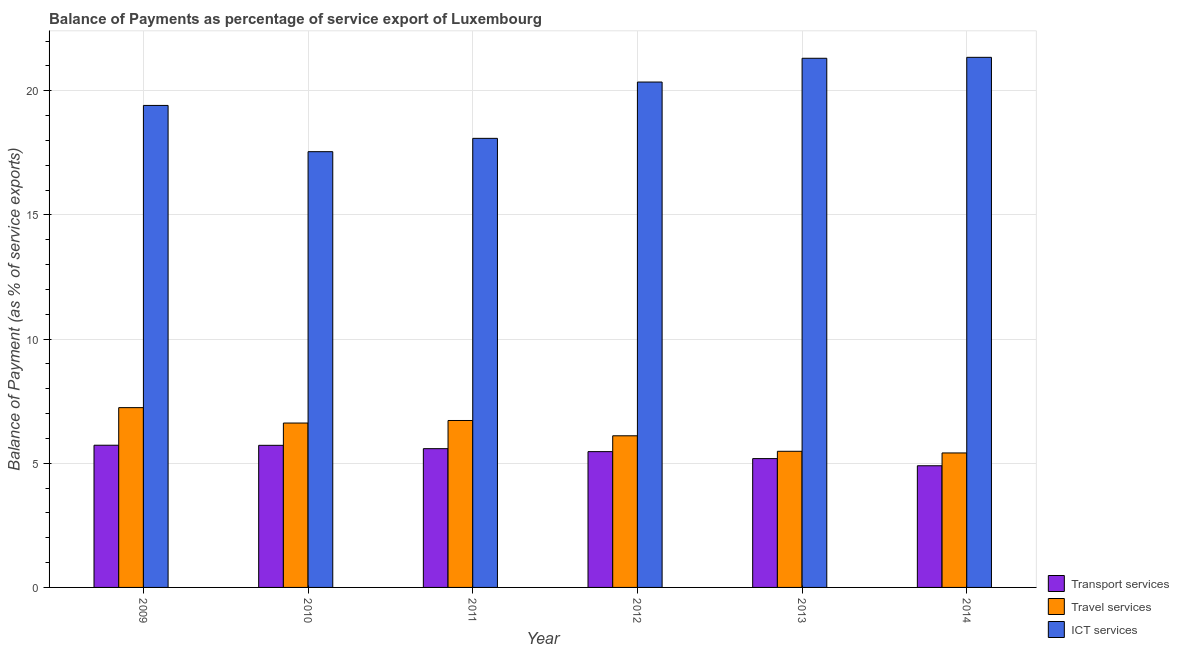How many groups of bars are there?
Provide a succinct answer. 6. Are the number of bars on each tick of the X-axis equal?
Provide a short and direct response. Yes. How many bars are there on the 3rd tick from the right?
Keep it short and to the point. 3. What is the balance of payment of ict services in 2011?
Give a very brief answer. 18.08. Across all years, what is the maximum balance of payment of travel services?
Offer a very short reply. 7.24. Across all years, what is the minimum balance of payment of ict services?
Offer a terse response. 17.55. In which year was the balance of payment of travel services maximum?
Provide a short and direct response. 2009. In which year was the balance of payment of travel services minimum?
Make the answer very short. 2014. What is the total balance of payment of transport services in the graph?
Provide a succinct answer. 32.59. What is the difference between the balance of payment of transport services in 2009 and that in 2012?
Provide a short and direct response. 0.26. What is the difference between the balance of payment of ict services in 2014 and the balance of payment of travel services in 2013?
Your answer should be very brief. 0.04. What is the average balance of payment of travel services per year?
Provide a short and direct response. 6.26. In the year 2013, what is the difference between the balance of payment of ict services and balance of payment of travel services?
Give a very brief answer. 0. In how many years, is the balance of payment of travel services greater than 1 %?
Your answer should be compact. 6. What is the ratio of the balance of payment of ict services in 2009 to that in 2010?
Ensure brevity in your answer.  1.11. Is the balance of payment of travel services in 2010 less than that in 2011?
Ensure brevity in your answer.  Yes. What is the difference between the highest and the second highest balance of payment of ict services?
Provide a succinct answer. 0.04. What is the difference between the highest and the lowest balance of payment of travel services?
Your answer should be very brief. 1.82. Is the sum of the balance of payment of travel services in 2009 and 2011 greater than the maximum balance of payment of ict services across all years?
Provide a short and direct response. Yes. What does the 3rd bar from the left in 2013 represents?
Your response must be concise. ICT services. What does the 2nd bar from the right in 2011 represents?
Your answer should be compact. Travel services. Is it the case that in every year, the sum of the balance of payment of transport services and balance of payment of travel services is greater than the balance of payment of ict services?
Offer a terse response. No. Are all the bars in the graph horizontal?
Offer a very short reply. No. How many years are there in the graph?
Offer a very short reply. 6. How many legend labels are there?
Your answer should be compact. 3. What is the title of the graph?
Provide a succinct answer. Balance of Payments as percentage of service export of Luxembourg. What is the label or title of the Y-axis?
Keep it short and to the point. Balance of Payment (as % of service exports). What is the Balance of Payment (as % of service exports) in Transport services in 2009?
Offer a very short reply. 5.73. What is the Balance of Payment (as % of service exports) of Travel services in 2009?
Ensure brevity in your answer.  7.24. What is the Balance of Payment (as % of service exports) in ICT services in 2009?
Give a very brief answer. 19.41. What is the Balance of Payment (as % of service exports) in Transport services in 2010?
Ensure brevity in your answer.  5.72. What is the Balance of Payment (as % of service exports) of Travel services in 2010?
Offer a very short reply. 6.62. What is the Balance of Payment (as % of service exports) of ICT services in 2010?
Provide a short and direct response. 17.55. What is the Balance of Payment (as % of service exports) in Transport services in 2011?
Your answer should be compact. 5.59. What is the Balance of Payment (as % of service exports) of Travel services in 2011?
Keep it short and to the point. 6.72. What is the Balance of Payment (as % of service exports) in ICT services in 2011?
Provide a short and direct response. 18.08. What is the Balance of Payment (as % of service exports) of Transport services in 2012?
Provide a short and direct response. 5.47. What is the Balance of Payment (as % of service exports) in Travel services in 2012?
Give a very brief answer. 6.11. What is the Balance of Payment (as % of service exports) in ICT services in 2012?
Your response must be concise. 20.35. What is the Balance of Payment (as % of service exports) in Transport services in 2013?
Make the answer very short. 5.19. What is the Balance of Payment (as % of service exports) of Travel services in 2013?
Offer a terse response. 5.48. What is the Balance of Payment (as % of service exports) in ICT services in 2013?
Offer a very short reply. 21.31. What is the Balance of Payment (as % of service exports) in Transport services in 2014?
Give a very brief answer. 4.9. What is the Balance of Payment (as % of service exports) in Travel services in 2014?
Make the answer very short. 5.41. What is the Balance of Payment (as % of service exports) of ICT services in 2014?
Ensure brevity in your answer.  21.34. Across all years, what is the maximum Balance of Payment (as % of service exports) of Transport services?
Keep it short and to the point. 5.73. Across all years, what is the maximum Balance of Payment (as % of service exports) in Travel services?
Your answer should be very brief. 7.24. Across all years, what is the maximum Balance of Payment (as % of service exports) of ICT services?
Provide a short and direct response. 21.34. Across all years, what is the minimum Balance of Payment (as % of service exports) of Transport services?
Make the answer very short. 4.9. Across all years, what is the minimum Balance of Payment (as % of service exports) in Travel services?
Provide a succinct answer. 5.41. Across all years, what is the minimum Balance of Payment (as % of service exports) in ICT services?
Offer a very short reply. 17.55. What is the total Balance of Payment (as % of service exports) of Transport services in the graph?
Ensure brevity in your answer.  32.59. What is the total Balance of Payment (as % of service exports) in Travel services in the graph?
Offer a terse response. 37.58. What is the total Balance of Payment (as % of service exports) of ICT services in the graph?
Keep it short and to the point. 118.04. What is the difference between the Balance of Payment (as % of service exports) in Transport services in 2009 and that in 2010?
Ensure brevity in your answer.  0. What is the difference between the Balance of Payment (as % of service exports) of Travel services in 2009 and that in 2010?
Keep it short and to the point. 0.62. What is the difference between the Balance of Payment (as % of service exports) of ICT services in 2009 and that in 2010?
Your answer should be very brief. 1.86. What is the difference between the Balance of Payment (as % of service exports) of Transport services in 2009 and that in 2011?
Your response must be concise. 0.14. What is the difference between the Balance of Payment (as % of service exports) of Travel services in 2009 and that in 2011?
Provide a short and direct response. 0.52. What is the difference between the Balance of Payment (as % of service exports) in ICT services in 2009 and that in 2011?
Provide a short and direct response. 1.33. What is the difference between the Balance of Payment (as % of service exports) of Transport services in 2009 and that in 2012?
Ensure brevity in your answer.  0.26. What is the difference between the Balance of Payment (as % of service exports) in Travel services in 2009 and that in 2012?
Ensure brevity in your answer.  1.13. What is the difference between the Balance of Payment (as % of service exports) in ICT services in 2009 and that in 2012?
Offer a terse response. -0.94. What is the difference between the Balance of Payment (as % of service exports) in Transport services in 2009 and that in 2013?
Your answer should be compact. 0.54. What is the difference between the Balance of Payment (as % of service exports) of Travel services in 2009 and that in 2013?
Your answer should be very brief. 1.76. What is the difference between the Balance of Payment (as % of service exports) in ICT services in 2009 and that in 2013?
Make the answer very short. -1.9. What is the difference between the Balance of Payment (as % of service exports) in Transport services in 2009 and that in 2014?
Ensure brevity in your answer.  0.83. What is the difference between the Balance of Payment (as % of service exports) of Travel services in 2009 and that in 2014?
Make the answer very short. 1.82. What is the difference between the Balance of Payment (as % of service exports) of ICT services in 2009 and that in 2014?
Provide a succinct answer. -1.94. What is the difference between the Balance of Payment (as % of service exports) of Transport services in 2010 and that in 2011?
Your answer should be compact. 0.13. What is the difference between the Balance of Payment (as % of service exports) in Travel services in 2010 and that in 2011?
Give a very brief answer. -0.1. What is the difference between the Balance of Payment (as % of service exports) of ICT services in 2010 and that in 2011?
Your answer should be very brief. -0.54. What is the difference between the Balance of Payment (as % of service exports) in Transport services in 2010 and that in 2012?
Offer a very short reply. 0.25. What is the difference between the Balance of Payment (as % of service exports) of Travel services in 2010 and that in 2012?
Ensure brevity in your answer.  0.51. What is the difference between the Balance of Payment (as % of service exports) in ICT services in 2010 and that in 2012?
Keep it short and to the point. -2.8. What is the difference between the Balance of Payment (as % of service exports) of Transport services in 2010 and that in 2013?
Your response must be concise. 0.54. What is the difference between the Balance of Payment (as % of service exports) in Travel services in 2010 and that in 2013?
Provide a succinct answer. 1.14. What is the difference between the Balance of Payment (as % of service exports) in ICT services in 2010 and that in 2013?
Provide a succinct answer. -3.76. What is the difference between the Balance of Payment (as % of service exports) of Transport services in 2010 and that in 2014?
Give a very brief answer. 0.82. What is the difference between the Balance of Payment (as % of service exports) of Travel services in 2010 and that in 2014?
Offer a very short reply. 1.2. What is the difference between the Balance of Payment (as % of service exports) of ICT services in 2010 and that in 2014?
Keep it short and to the point. -3.8. What is the difference between the Balance of Payment (as % of service exports) in Transport services in 2011 and that in 2012?
Offer a very short reply. 0.12. What is the difference between the Balance of Payment (as % of service exports) of Travel services in 2011 and that in 2012?
Ensure brevity in your answer.  0.62. What is the difference between the Balance of Payment (as % of service exports) of ICT services in 2011 and that in 2012?
Offer a very short reply. -2.27. What is the difference between the Balance of Payment (as % of service exports) in Transport services in 2011 and that in 2013?
Provide a succinct answer. 0.4. What is the difference between the Balance of Payment (as % of service exports) of Travel services in 2011 and that in 2013?
Your response must be concise. 1.24. What is the difference between the Balance of Payment (as % of service exports) in ICT services in 2011 and that in 2013?
Your answer should be compact. -3.22. What is the difference between the Balance of Payment (as % of service exports) of Transport services in 2011 and that in 2014?
Provide a succinct answer. 0.69. What is the difference between the Balance of Payment (as % of service exports) in Travel services in 2011 and that in 2014?
Provide a short and direct response. 1.31. What is the difference between the Balance of Payment (as % of service exports) in ICT services in 2011 and that in 2014?
Your answer should be compact. -3.26. What is the difference between the Balance of Payment (as % of service exports) of Transport services in 2012 and that in 2013?
Provide a short and direct response. 0.28. What is the difference between the Balance of Payment (as % of service exports) in Travel services in 2012 and that in 2013?
Your response must be concise. 0.62. What is the difference between the Balance of Payment (as % of service exports) in ICT services in 2012 and that in 2013?
Your answer should be very brief. -0.96. What is the difference between the Balance of Payment (as % of service exports) of Transport services in 2012 and that in 2014?
Offer a terse response. 0.57. What is the difference between the Balance of Payment (as % of service exports) of Travel services in 2012 and that in 2014?
Give a very brief answer. 0.69. What is the difference between the Balance of Payment (as % of service exports) in ICT services in 2012 and that in 2014?
Keep it short and to the point. -0.99. What is the difference between the Balance of Payment (as % of service exports) in Transport services in 2013 and that in 2014?
Your answer should be compact. 0.29. What is the difference between the Balance of Payment (as % of service exports) of Travel services in 2013 and that in 2014?
Make the answer very short. 0.07. What is the difference between the Balance of Payment (as % of service exports) of ICT services in 2013 and that in 2014?
Ensure brevity in your answer.  -0.04. What is the difference between the Balance of Payment (as % of service exports) in Transport services in 2009 and the Balance of Payment (as % of service exports) in Travel services in 2010?
Your answer should be compact. -0.89. What is the difference between the Balance of Payment (as % of service exports) of Transport services in 2009 and the Balance of Payment (as % of service exports) of ICT services in 2010?
Your answer should be compact. -11.82. What is the difference between the Balance of Payment (as % of service exports) of Travel services in 2009 and the Balance of Payment (as % of service exports) of ICT services in 2010?
Make the answer very short. -10.31. What is the difference between the Balance of Payment (as % of service exports) in Transport services in 2009 and the Balance of Payment (as % of service exports) in Travel services in 2011?
Give a very brief answer. -1. What is the difference between the Balance of Payment (as % of service exports) of Transport services in 2009 and the Balance of Payment (as % of service exports) of ICT services in 2011?
Your response must be concise. -12.36. What is the difference between the Balance of Payment (as % of service exports) of Travel services in 2009 and the Balance of Payment (as % of service exports) of ICT services in 2011?
Provide a succinct answer. -10.84. What is the difference between the Balance of Payment (as % of service exports) of Transport services in 2009 and the Balance of Payment (as % of service exports) of Travel services in 2012?
Provide a short and direct response. -0.38. What is the difference between the Balance of Payment (as % of service exports) in Transport services in 2009 and the Balance of Payment (as % of service exports) in ICT services in 2012?
Give a very brief answer. -14.62. What is the difference between the Balance of Payment (as % of service exports) of Travel services in 2009 and the Balance of Payment (as % of service exports) of ICT services in 2012?
Make the answer very short. -13.11. What is the difference between the Balance of Payment (as % of service exports) in Transport services in 2009 and the Balance of Payment (as % of service exports) in Travel services in 2013?
Provide a short and direct response. 0.24. What is the difference between the Balance of Payment (as % of service exports) of Transport services in 2009 and the Balance of Payment (as % of service exports) of ICT services in 2013?
Your answer should be very brief. -15.58. What is the difference between the Balance of Payment (as % of service exports) in Travel services in 2009 and the Balance of Payment (as % of service exports) in ICT services in 2013?
Your answer should be very brief. -14.07. What is the difference between the Balance of Payment (as % of service exports) of Transport services in 2009 and the Balance of Payment (as % of service exports) of Travel services in 2014?
Ensure brevity in your answer.  0.31. What is the difference between the Balance of Payment (as % of service exports) in Transport services in 2009 and the Balance of Payment (as % of service exports) in ICT services in 2014?
Your response must be concise. -15.62. What is the difference between the Balance of Payment (as % of service exports) of Travel services in 2009 and the Balance of Payment (as % of service exports) of ICT services in 2014?
Offer a terse response. -14.11. What is the difference between the Balance of Payment (as % of service exports) of Transport services in 2010 and the Balance of Payment (as % of service exports) of Travel services in 2011?
Offer a very short reply. -1. What is the difference between the Balance of Payment (as % of service exports) of Transport services in 2010 and the Balance of Payment (as % of service exports) of ICT services in 2011?
Ensure brevity in your answer.  -12.36. What is the difference between the Balance of Payment (as % of service exports) in Travel services in 2010 and the Balance of Payment (as % of service exports) in ICT services in 2011?
Keep it short and to the point. -11.46. What is the difference between the Balance of Payment (as % of service exports) in Transport services in 2010 and the Balance of Payment (as % of service exports) in Travel services in 2012?
Your answer should be very brief. -0.38. What is the difference between the Balance of Payment (as % of service exports) in Transport services in 2010 and the Balance of Payment (as % of service exports) in ICT services in 2012?
Your answer should be compact. -14.63. What is the difference between the Balance of Payment (as % of service exports) in Travel services in 2010 and the Balance of Payment (as % of service exports) in ICT services in 2012?
Offer a terse response. -13.73. What is the difference between the Balance of Payment (as % of service exports) in Transport services in 2010 and the Balance of Payment (as % of service exports) in Travel services in 2013?
Offer a terse response. 0.24. What is the difference between the Balance of Payment (as % of service exports) of Transport services in 2010 and the Balance of Payment (as % of service exports) of ICT services in 2013?
Your response must be concise. -15.58. What is the difference between the Balance of Payment (as % of service exports) in Travel services in 2010 and the Balance of Payment (as % of service exports) in ICT services in 2013?
Your answer should be compact. -14.69. What is the difference between the Balance of Payment (as % of service exports) of Transport services in 2010 and the Balance of Payment (as % of service exports) of Travel services in 2014?
Your response must be concise. 0.31. What is the difference between the Balance of Payment (as % of service exports) in Transport services in 2010 and the Balance of Payment (as % of service exports) in ICT services in 2014?
Keep it short and to the point. -15.62. What is the difference between the Balance of Payment (as % of service exports) in Travel services in 2010 and the Balance of Payment (as % of service exports) in ICT services in 2014?
Make the answer very short. -14.73. What is the difference between the Balance of Payment (as % of service exports) of Transport services in 2011 and the Balance of Payment (as % of service exports) of Travel services in 2012?
Give a very brief answer. -0.52. What is the difference between the Balance of Payment (as % of service exports) in Transport services in 2011 and the Balance of Payment (as % of service exports) in ICT services in 2012?
Provide a short and direct response. -14.76. What is the difference between the Balance of Payment (as % of service exports) of Travel services in 2011 and the Balance of Payment (as % of service exports) of ICT services in 2012?
Give a very brief answer. -13.63. What is the difference between the Balance of Payment (as % of service exports) in Transport services in 2011 and the Balance of Payment (as % of service exports) in Travel services in 2013?
Make the answer very short. 0.11. What is the difference between the Balance of Payment (as % of service exports) in Transport services in 2011 and the Balance of Payment (as % of service exports) in ICT services in 2013?
Offer a very short reply. -15.72. What is the difference between the Balance of Payment (as % of service exports) of Travel services in 2011 and the Balance of Payment (as % of service exports) of ICT services in 2013?
Provide a succinct answer. -14.59. What is the difference between the Balance of Payment (as % of service exports) in Transport services in 2011 and the Balance of Payment (as % of service exports) in Travel services in 2014?
Make the answer very short. 0.17. What is the difference between the Balance of Payment (as % of service exports) of Transport services in 2011 and the Balance of Payment (as % of service exports) of ICT services in 2014?
Offer a terse response. -15.76. What is the difference between the Balance of Payment (as % of service exports) in Travel services in 2011 and the Balance of Payment (as % of service exports) in ICT services in 2014?
Provide a short and direct response. -14.62. What is the difference between the Balance of Payment (as % of service exports) of Transport services in 2012 and the Balance of Payment (as % of service exports) of Travel services in 2013?
Your answer should be compact. -0.01. What is the difference between the Balance of Payment (as % of service exports) of Transport services in 2012 and the Balance of Payment (as % of service exports) of ICT services in 2013?
Give a very brief answer. -15.84. What is the difference between the Balance of Payment (as % of service exports) of Travel services in 2012 and the Balance of Payment (as % of service exports) of ICT services in 2013?
Ensure brevity in your answer.  -15.2. What is the difference between the Balance of Payment (as % of service exports) in Transport services in 2012 and the Balance of Payment (as % of service exports) in Travel services in 2014?
Make the answer very short. 0.05. What is the difference between the Balance of Payment (as % of service exports) in Transport services in 2012 and the Balance of Payment (as % of service exports) in ICT services in 2014?
Your answer should be compact. -15.88. What is the difference between the Balance of Payment (as % of service exports) in Travel services in 2012 and the Balance of Payment (as % of service exports) in ICT services in 2014?
Make the answer very short. -15.24. What is the difference between the Balance of Payment (as % of service exports) of Transport services in 2013 and the Balance of Payment (as % of service exports) of Travel services in 2014?
Provide a short and direct response. -0.23. What is the difference between the Balance of Payment (as % of service exports) in Transport services in 2013 and the Balance of Payment (as % of service exports) in ICT services in 2014?
Ensure brevity in your answer.  -16.16. What is the difference between the Balance of Payment (as % of service exports) in Travel services in 2013 and the Balance of Payment (as % of service exports) in ICT services in 2014?
Offer a very short reply. -15.86. What is the average Balance of Payment (as % of service exports) in Transport services per year?
Offer a very short reply. 5.43. What is the average Balance of Payment (as % of service exports) in Travel services per year?
Give a very brief answer. 6.26. What is the average Balance of Payment (as % of service exports) of ICT services per year?
Make the answer very short. 19.67. In the year 2009, what is the difference between the Balance of Payment (as % of service exports) of Transport services and Balance of Payment (as % of service exports) of Travel services?
Provide a succinct answer. -1.51. In the year 2009, what is the difference between the Balance of Payment (as % of service exports) in Transport services and Balance of Payment (as % of service exports) in ICT services?
Your answer should be compact. -13.68. In the year 2009, what is the difference between the Balance of Payment (as % of service exports) of Travel services and Balance of Payment (as % of service exports) of ICT services?
Offer a very short reply. -12.17. In the year 2010, what is the difference between the Balance of Payment (as % of service exports) of Transport services and Balance of Payment (as % of service exports) of Travel services?
Offer a terse response. -0.9. In the year 2010, what is the difference between the Balance of Payment (as % of service exports) of Transport services and Balance of Payment (as % of service exports) of ICT services?
Keep it short and to the point. -11.82. In the year 2010, what is the difference between the Balance of Payment (as % of service exports) in Travel services and Balance of Payment (as % of service exports) in ICT services?
Offer a very short reply. -10.93. In the year 2011, what is the difference between the Balance of Payment (as % of service exports) of Transport services and Balance of Payment (as % of service exports) of Travel services?
Ensure brevity in your answer.  -1.13. In the year 2011, what is the difference between the Balance of Payment (as % of service exports) of Transport services and Balance of Payment (as % of service exports) of ICT services?
Give a very brief answer. -12.49. In the year 2011, what is the difference between the Balance of Payment (as % of service exports) of Travel services and Balance of Payment (as % of service exports) of ICT services?
Make the answer very short. -11.36. In the year 2012, what is the difference between the Balance of Payment (as % of service exports) in Transport services and Balance of Payment (as % of service exports) in Travel services?
Offer a very short reply. -0.64. In the year 2012, what is the difference between the Balance of Payment (as % of service exports) in Transport services and Balance of Payment (as % of service exports) in ICT services?
Offer a very short reply. -14.88. In the year 2012, what is the difference between the Balance of Payment (as % of service exports) of Travel services and Balance of Payment (as % of service exports) of ICT services?
Ensure brevity in your answer.  -14.24. In the year 2013, what is the difference between the Balance of Payment (as % of service exports) of Transport services and Balance of Payment (as % of service exports) of Travel services?
Offer a terse response. -0.29. In the year 2013, what is the difference between the Balance of Payment (as % of service exports) in Transport services and Balance of Payment (as % of service exports) in ICT services?
Give a very brief answer. -16.12. In the year 2013, what is the difference between the Balance of Payment (as % of service exports) in Travel services and Balance of Payment (as % of service exports) in ICT services?
Offer a very short reply. -15.83. In the year 2014, what is the difference between the Balance of Payment (as % of service exports) in Transport services and Balance of Payment (as % of service exports) in Travel services?
Keep it short and to the point. -0.52. In the year 2014, what is the difference between the Balance of Payment (as % of service exports) in Transport services and Balance of Payment (as % of service exports) in ICT services?
Keep it short and to the point. -16.45. In the year 2014, what is the difference between the Balance of Payment (as % of service exports) in Travel services and Balance of Payment (as % of service exports) in ICT services?
Your response must be concise. -15.93. What is the ratio of the Balance of Payment (as % of service exports) in Transport services in 2009 to that in 2010?
Your answer should be compact. 1. What is the ratio of the Balance of Payment (as % of service exports) of Travel services in 2009 to that in 2010?
Ensure brevity in your answer.  1.09. What is the ratio of the Balance of Payment (as % of service exports) of ICT services in 2009 to that in 2010?
Your response must be concise. 1.11. What is the ratio of the Balance of Payment (as % of service exports) of Transport services in 2009 to that in 2011?
Your response must be concise. 1.02. What is the ratio of the Balance of Payment (as % of service exports) in Travel services in 2009 to that in 2011?
Provide a short and direct response. 1.08. What is the ratio of the Balance of Payment (as % of service exports) of ICT services in 2009 to that in 2011?
Offer a very short reply. 1.07. What is the ratio of the Balance of Payment (as % of service exports) of Transport services in 2009 to that in 2012?
Provide a short and direct response. 1.05. What is the ratio of the Balance of Payment (as % of service exports) of Travel services in 2009 to that in 2012?
Keep it short and to the point. 1.19. What is the ratio of the Balance of Payment (as % of service exports) in ICT services in 2009 to that in 2012?
Provide a short and direct response. 0.95. What is the ratio of the Balance of Payment (as % of service exports) in Transport services in 2009 to that in 2013?
Ensure brevity in your answer.  1.1. What is the ratio of the Balance of Payment (as % of service exports) in Travel services in 2009 to that in 2013?
Ensure brevity in your answer.  1.32. What is the ratio of the Balance of Payment (as % of service exports) of ICT services in 2009 to that in 2013?
Your response must be concise. 0.91. What is the ratio of the Balance of Payment (as % of service exports) of Transport services in 2009 to that in 2014?
Offer a terse response. 1.17. What is the ratio of the Balance of Payment (as % of service exports) of Travel services in 2009 to that in 2014?
Offer a very short reply. 1.34. What is the ratio of the Balance of Payment (as % of service exports) of ICT services in 2009 to that in 2014?
Your answer should be compact. 0.91. What is the ratio of the Balance of Payment (as % of service exports) in Transport services in 2010 to that in 2011?
Provide a short and direct response. 1.02. What is the ratio of the Balance of Payment (as % of service exports) in Travel services in 2010 to that in 2011?
Ensure brevity in your answer.  0.98. What is the ratio of the Balance of Payment (as % of service exports) in ICT services in 2010 to that in 2011?
Provide a short and direct response. 0.97. What is the ratio of the Balance of Payment (as % of service exports) in Transport services in 2010 to that in 2012?
Ensure brevity in your answer.  1.05. What is the ratio of the Balance of Payment (as % of service exports) of Travel services in 2010 to that in 2012?
Your response must be concise. 1.08. What is the ratio of the Balance of Payment (as % of service exports) in ICT services in 2010 to that in 2012?
Provide a short and direct response. 0.86. What is the ratio of the Balance of Payment (as % of service exports) in Transport services in 2010 to that in 2013?
Offer a terse response. 1.1. What is the ratio of the Balance of Payment (as % of service exports) in Travel services in 2010 to that in 2013?
Offer a terse response. 1.21. What is the ratio of the Balance of Payment (as % of service exports) of ICT services in 2010 to that in 2013?
Ensure brevity in your answer.  0.82. What is the ratio of the Balance of Payment (as % of service exports) in Transport services in 2010 to that in 2014?
Offer a terse response. 1.17. What is the ratio of the Balance of Payment (as % of service exports) of Travel services in 2010 to that in 2014?
Ensure brevity in your answer.  1.22. What is the ratio of the Balance of Payment (as % of service exports) of ICT services in 2010 to that in 2014?
Give a very brief answer. 0.82. What is the ratio of the Balance of Payment (as % of service exports) of Transport services in 2011 to that in 2012?
Provide a succinct answer. 1.02. What is the ratio of the Balance of Payment (as % of service exports) of Travel services in 2011 to that in 2012?
Ensure brevity in your answer.  1.1. What is the ratio of the Balance of Payment (as % of service exports) of ICT services in 2011 to that in 2012?
Provide a short and direct response. 0.89. What is the ratio of the Balance of Payment (as % of service exports) in Transport services in 2011 to that in 2013?
Provide a short and direct response. 1.08. What is the ratio of the Balance of Payment (as % of service exports) in Travel services in 2011 to that in 2013?
Keep it short and to the point. 1.23. What is the ratio of the Balance of Payment (as % of service exports) of ICT services in 2011 to that in 2013?
Provide a succinct answer. 0.85. What is the ratio of the Balance of Payment (as % of service exports) in Transport services in 2011 to that in 2014?
Your answer should be compact. 1.14. What is the ratio of the Balance of Payment (as % of service exports) in Travel services in 2011 to that in 2014?
Your answer should be compact. 1.24. What is the ratio of the Balance of Payment (as % of service exports) in ICT services in 2011 to that in 2014?
Offer a terse response. 0.85. What is the ratio of the Balance of Payment (as % of service exports) of Transport services in 2012 to that in 2013?
Your answer should be compact. 1.05. What is the ratio of the Balance of Payment (as % of service exports) of Travel services in 2012 to that in 2013?
Make the answer very short. 1.11. What is the ratio of the Balance of Payment (as % of service exports) in ICT services in 2012 to that in 2013?
Offer a terse response. 0.96. What is the ratio of the Balance of Payment (as % of service exports) of Transport services in 2012 to that in 2014?
Offer a terse response. 1.12. What is the ratio of the Balance of Payment (as % of service exports) of Travel services in 2012 to that in 2014?
Offer a terse response. 1.13. What is the ratio of the Balance of Payment (as % of service exports) of ICT services in 2012 to that in 2014?
Give a very brief answer. 0.95. What is the ratio of the Balance of Payment (as % of service exports) of Transport services in 2013 to that in 2014?
Make the answer very short. 1.06. What is the ratio of the Balance of Payment (as % of service exports) in Travel services in 2013 to that in 2014?
Your response must be concise. 1.01. What is the ratio of the Balance of Payment (as % of service exports) of ICT services in 2013 to that in 2014?
Your answer should be very brief. 1. What is the difference between the highest and the second highest Balance of Payment (as % of service exports) of Transport services?
Keep it short and to the point. 0. What is the difference between the highest and the second highest Balance of Payment (as % of service exports) in Travel services?
Your answer should be very brief. 0.52. What is the difference between the highest and the second highest Balance of Payment (as % of service exports) in ICT services?
Provide a succinct answer. 0.04. What is the difference between the highest and the lowest Balance of Payment (as % of service exports) in Transport services?
Offer a very short reply. 0.83. What is the difference between the highest and the lowest Balance of Payment (as % of service exports) of Travel services?
Offer a very short reply. 1.82. What is the difference between the highest and the lowest Balance of Payment (as % of service exports) of ICT services?
Your answer should be compact. 3.8. 